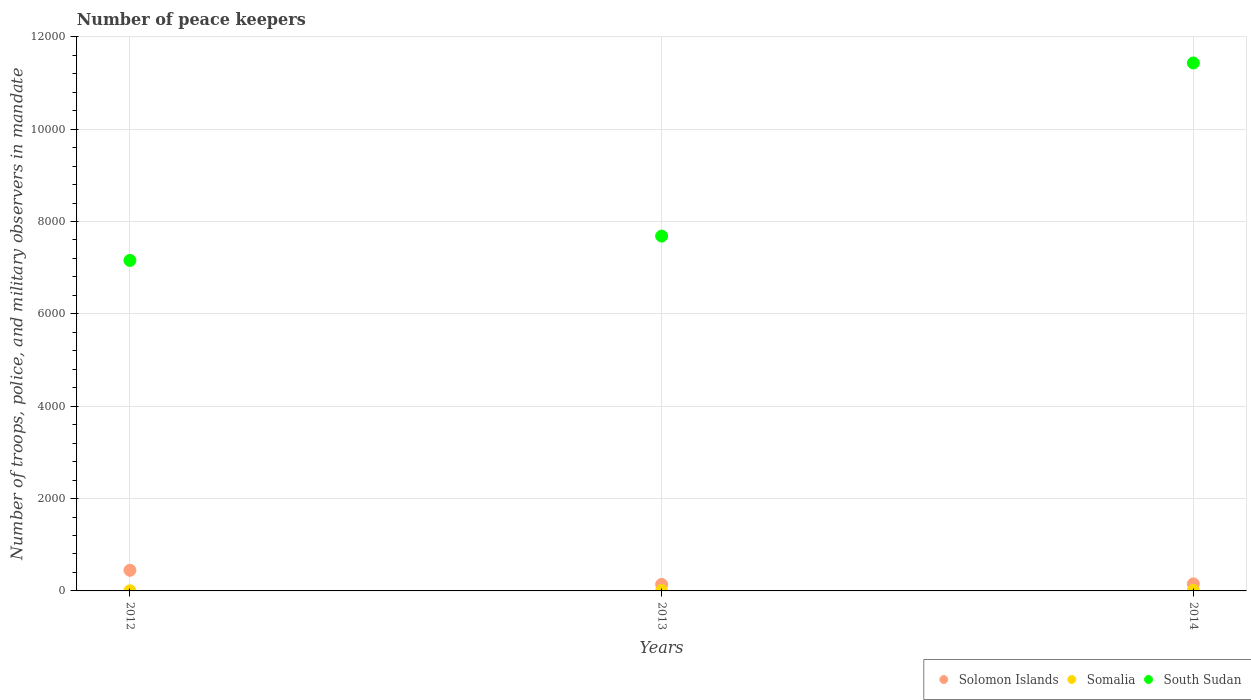Across all years, what is the maximum number of peace keepers in in South Sudan?
Your response must be concise. 1.14e+04. Across all years, what is the minimum number of peace keepers in in South Sudan?
Provide a short and direct response. 7157. In which year was the number of peace keepers in in South Sudan maximum?
Keep it short and to the point. 2014. In which year was the number of peace keepers in in Somalia minimum?
Your answer should be compact. 2012. What is the total number of peace keepers in in Somalia in the graph?
Make the answer very short. 24. What is the difference between the number of peace keepers in in Solomon Islands in 2013 and that in 2014?
Provide a short and direct response. -11. What is the difference between the number of peace keepers in in South Sudan in 2014 and the number of peace keepers in in Somalia in 2012?
Offer a very short reply. 1.14e+04. In the year 2014, what is the difference between the number of peace keepers in in Solomon Islands and number of peace keepers in in Somalia?
Offer a terse response. 140. What is the ratio of the number of peace keepers in in South Sudan in 2012 to that in 2014?
Provide a short and direct response. 0.63. Is the difference between the number of peace keepers in in Solomon Islands in 2013 and 2014 greater than the difference between the number of peace keepers in in Somalia in 2013 and 2014?
Provide a short and direct response. No. What is the difference between the highest and the second highest number of peace keepers in in Solomon Islands?
Your answer should be compact. 295. Is it the case that in every year, the sum of the number of peace keepers in in Somalia and number of peace keepers in in South Sudan  is greater than the number of peace keepers in in Solomon Islands?
Provide a succinct answer. Yes. Is the number of peace keepers in in South Sudan strictly less than the number of peace keepers in in Solomon Islands over the years?
Make the answer very short. No. How many dotlines are there?
Your response must be concise. 3. How many years are there in the graph?
Your response must be concise. 3. What is the difference between two consecutive major ticks on the Y-axis?
Offer a very short reply. 2000. Does the graph contain any zero values?
Give a very brief answer. No. Does the graph contain grids?
Your answer should be compact. Yes. How many legend labels are there?
Make the answer very short. 3. How are the legend labels stacked?
Your answer should be compact. Horizontal. What is the title of the graph?
Provide a succinct answer. Number of peace keepers. What is the label or title of the Y-axis?
Give a very brief answer. Number of troops, police, and military observers in mandate. What is the Number of troops, police, and military observers in mandate in Solomon Islands in 2012?
Offer a terse response. 447. What is the Number of troops, police, and military observers in mandate in South Sudan in 2012?
Your response must be concise. 7157. What is the Number of troops, police, and military observers in mandate of Solomon Islands in 2013?
Offer a very short reply. 141. What is the Number of troops, police, and military observers in mandate of Somalia in 2013?
Your answer should be very brief. 9. What is the Number of troops, police, and military observers in mandate in South Sudan in 2013?
Make the answer very short. 7684. What is the Number of troops, police, and military observers in mandate in Solomon Islands in 2014?
Offer a very short reply. 152. What is the Number of troops, police, and military observers in mandate of South Sudan in 2014?
Make the answer very short. 1.14e+04. Across all years, what is the maximum Number of troops, police, and military observers in mandate in Solomon Islands?
Make the answer very short. 447. Across all years, what is the maximum Number of troops, police, and military observers in mandate in South Sudan?
Your response must be concise. 1.14e+04. Across all years, what is the minimum Number of troops, police, and military observers in mandate in Solomon Islands?
Your answer should be very brief. 141. Across all years, what is the minimum Number of troops, police, and military observers in mandate of South Sudan?
Provide a succinct answer. 7157. What is the total Number of troops, police, and military observers in mandate of Solomon Islands in the graph?
Ensure brevity in your answer.  740. What is the total Number of troops, police, and military observers in mandate in Somalia in the graph?
Provide a succinct answer. 24. What is the total Number of troops, police, and military observers in mandate of South Sudan in the graph?
Your response must be concise. 2.63e+04. What is the difference between the Number of troops, police, and military observers in mandate in Solomon Islands in 2012 and that in 2013?
Make the answer very short. 306. What is the difference between the Number of troops, police, and military observers in mandate in South Sudan in 2012 and that in 2013?
Give a very brief answer. -527. What is the difference between the Number of troops, police, and military observers in mandate of Solomon Islands in 2012 and that in 2014?
Give a very brief answer. 295. What is the difference between the Number of troops, police, and military observers in mandate in South Sudan in 2012 and that in 2014?
Ensure brevity in your answer.  -4276. What is the difference between the Number of troops, police, and military observers in mandate of Solomon Islands in 2013 and that in 2014?
Provide a short and direct response. -11. What is the difference between the Number of troops, police, and military observers in mandate of Somalia in 2013 and that in 2014?
Keep it short and to the point. -3. What is the difference between the Number of troops, police, and military observers in mandate of South Sudan in 2013 and that in 2014?
Ensure brevity in your answer.  -3749. What is the difference between the Number of troops, police, and military observers in mandate in Solomon Islands in 2012 and the Number of troops, police, and military observers in mandate in Somalia in 2013?
Give a very brief answer. 438. What is the difference between the Number of troops, police, and military observers in mandate in Solomon Islands in 2012 and the Number of troops, police, and military observers in mandate in South Sudan in 2013?
Keep it short and to the point. -7237. What is the difference between the Number of troops, police, and military observers in mandate in Somalia in 2012 and the Number of troops, police, and military observers in mandate in South Sudan in 2013?
Make the answer very short. -7681. What is the difference between the Number of troops, police, and military observers in mandate in Solomon Islands in 2012 and the Number of troops, police, and military observers in mandate in Somalia in 2014?
Offer a terse response. 435. What is the difference between the Number of troops, police, and military observers in mandate of Solomon Islands in 2012 and the Number of troops, police, and military observers in mandate of South Sudan in 2014?
Provide a succinct answer. -1.10e+04. What is the difference between the Number of troops, police, and military observers in mandate of Somalia in 2012 and the Number of troops, police, and military observers in mandate of South Sudan in 2014?
Ensure brevity in your answer.  -1.14e+04. What is the difference between the Number of troops, police, and military observers in mandate of Solomon Islands in 2013 and the Number of troops, police, and military observers in mandate of Somalia in 2014?
Provide a succinct answer. 129. What is the difference between the Number of troops, police, and military observers in mandate in Solomon Islands in 2013 and the Number of troops, police, and military observers in mandate in South Sudan in 2014?
Your answer should be compact. -1.13e+04. What is the difference between the Number of troops, police, and military observers in mandate in Somalia in 2013 and the Number of troops, police, and military observers in mandate in South Sudan in 2014?
Offer a terse response. -1.14e+04. What is the average Number of troops, police, and military observers in mandate of Solomon Islands per year?
Offer a terse response. 246.67. What is the average Number of troops, police, and military observers in mandate in South Sudan per year?
Your response must be concise. 8758. In the year 2012, what is the difference between the Number of troops, police, and military observers in mandate in Solomon Islands and Number of troops, police, and military observers in mandate in Somalia?
Provide a short and direct response. 444. In the year 2012, what is the difference between the Number of troops, police, and military observers in mandate in Solomon Islands and Number of troops, police, and military observers in mandate in South Sudan?
Provide a short and direct response. -6710. In the year 2012, what is the difference between the Number of troops, police, and military observers in mandate of Somalia and Number of troops, police, and military observers in mandate of South Sudan?
Make the answer very short. -7154. In the year 2013, what is the difference between the Number of troops, police, and military observers in mandate in Solomon Islands and Number of troops, police, and military observers in mandate in Somalia?
Provide a succinct answer. 132. In the year 2013, what is the difference between the Number of troops, police, and military observers in mandate of Solomon Islands and Number of troops, police, and military observers in mandate of South Sudan?
Your answer should be compact. -7543. In the year 2013, what is the difference between the Number of troops, police, and military observers in mandate in Somalia and Number of troops, police, and military observers in mandate in South Sudan?
Your answer should be very brief. -7675. In the year 2014, what is the difference between the Number of troops, police, and military observers in mandate of Solomon Islands and Number of troops, police, and military observers in mandate of Somalia?
Offer a very short reply. 140. In the year 2014, what is the difference between the Number of troops, police, and military observers in mandate of Solomon Islands and Number of troops, police, and military observers in mandate of South Sudan?
Provide a short and direct response. -1.13e+04. In the year 2014, what is the difference between the Number of troops, police, and military observers in mandate of Somalia and Number of troops, police, and military observers in mandate of South Sudan?
Offer a very short reply. -1.14e+04. What is the ratio of the Number of troops, police, and military observers in mandate of Solomon Islands in 2012 to that in 2013?
Provide a succinct answer. 3.17. What is the ratio of the Number of troops, police, and military observers in mandate of Somalia in 2012 to that in 2013?
Provide a succinct answer. 0.33. What is the ratio of the Number of troops, police, and military observers in mandate of South Sudan in 2012 to that in 2013?
Give a very brief answer. 0.93. What is the ratio of the Number of troops, police, and military observers in mandate in Solomon Islands in 2012 to that in 2014?
Provide a short and direct response. 2.94. What is the ratio of the Number of troops, police, and military observers in mandate in Somalia in 2012 to that in 2014?
Give a very brief answer. 0.25. What is the ratio of the Number of troops, police, and military observers in mandate of South Sudan in 2012 to that in 2014?
Keep it short and to the point. 0.63. What is the ratio of the Number of troops, police, and military observers in mandate of Solomon Islands in 2013 to that in 2014?
Provide a succinct answer. 0.93. What is the ratio of the Number of troops, police, and military observers in mandate of Somalia in 2013 to that in 2014?
Offer a terse response. 0.75. What is the ratio of the Number of troops, police, and military observers in mandate of South Sudan in 2013 to that in 2014?
Offer a very short reply. 0.67. What is the difference between the highest and the second highest Number of troops, police, and military observers in mandate of Solomon Islands?
Your answer should be very brief. 295. What is the difference between the highest and the second highest Number of troops, police, and military observers in mandate in South Sudan?
Your answer should be very brief. 3749. What is the difference between the highest and the lowest Number of troops, police, and military observers in mandate in Solomon Islands?
Your answer should be very brief. 306. What is the difference between the highest and the lowest Number of troops, police, and military observers in mandate in South Sudan?
Give a very brief answer. 4276. 